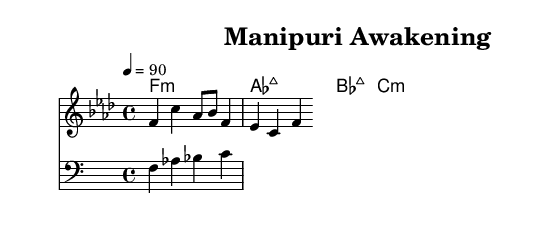What is the key signature of this music? The key signature is F minor, indicated by four flats in the music notation.
Answer: F minor What is the time signature of this composition? The time signature is 4/4, which can be found at the beginning of the score next to the key signature.
Answer: 4/4 What is the tempo marking of this piece? The tempo marking is provided as 4 = 90, suggesting the beat count and desired speed of the piece.
Answer: 90 What are the first three notes of the melody? The first three notes of the melody, as written, are f, c, and aes.
Answer: f, c, aes How many chords are played in the harmony section? There are four chords listed: f minor, a flat major, b flat major, and c minor. Each chord is clearly written in the chord names section.
Answer: 4 What type of music does this sheet represent? This sheet represents hip hop, specifically focused on socially conscious rap addressing Manipuri societal issues, as deduced from musical and cultural context.
Answer: Hip hop Which chord corresponds to the fourth bar of the harmonies? The chord in the fourth bar is c minor, as it is listed last in the chord progression.
Answer: c minor 